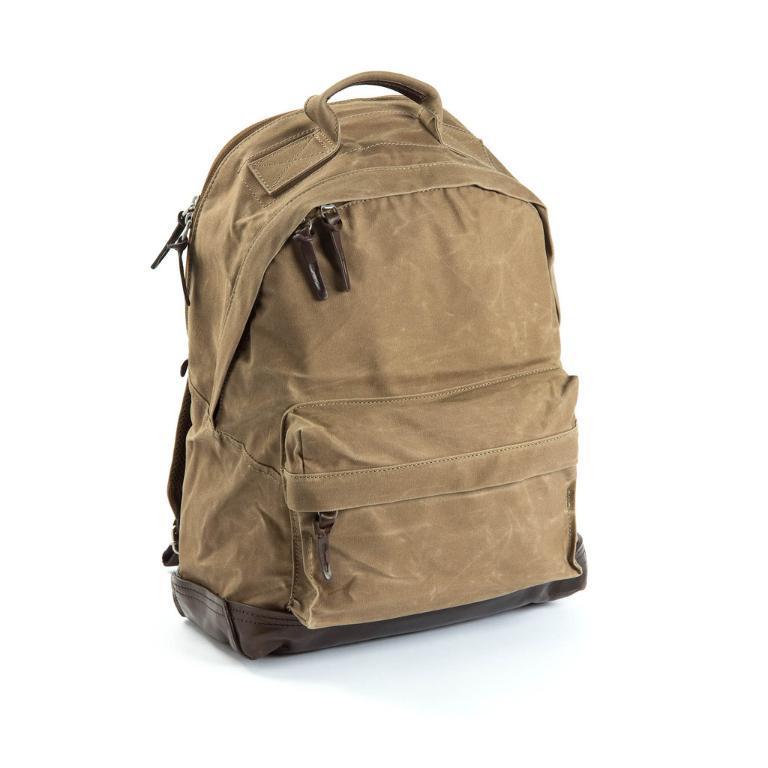In one or two sentences, can you explain what this image depicts? This is the picture of a brown bag. Background of this bag is in white color. 